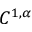Convert formula to latex. <formula><loc_0><loc_0><loc_500><loc_500>C ^ { 1 , \alpha }</formula> 